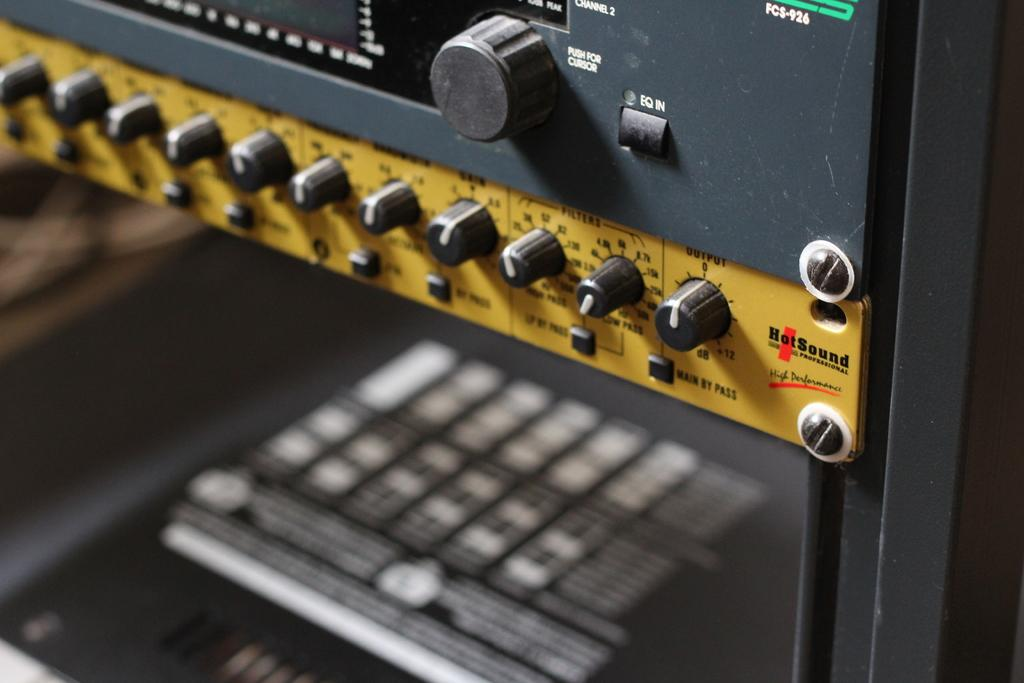What is the main subject in the image? There is an equipment in the image. What color are the items on the equipment? There are black color things on the equipment. Is there any text or writing on the equipment? Yes, there is writing on the equipment. Can you describe the quality of the image at the bottom? The bottom of the image is blurred. What is the opinion of the room in the image? There is no room present in the image, so it's not possible to determine an opinion about it. How does the equipment say good-bye in the image? The equipment does not have the ability to say good-bye, as it is an inanimate object. 